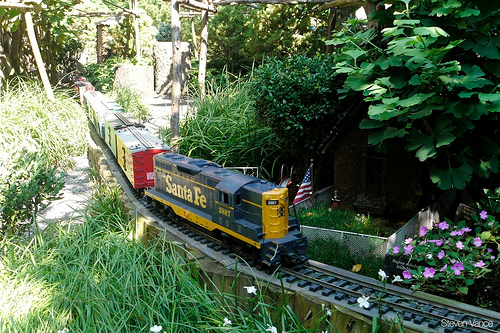Please provide the bounding box coordinate of the region this sentence describes: small american flag in the ground. The small American flag on the ground is located within the bounding box coordinates [0.59, 0.49, 0.63, 0.6]. 